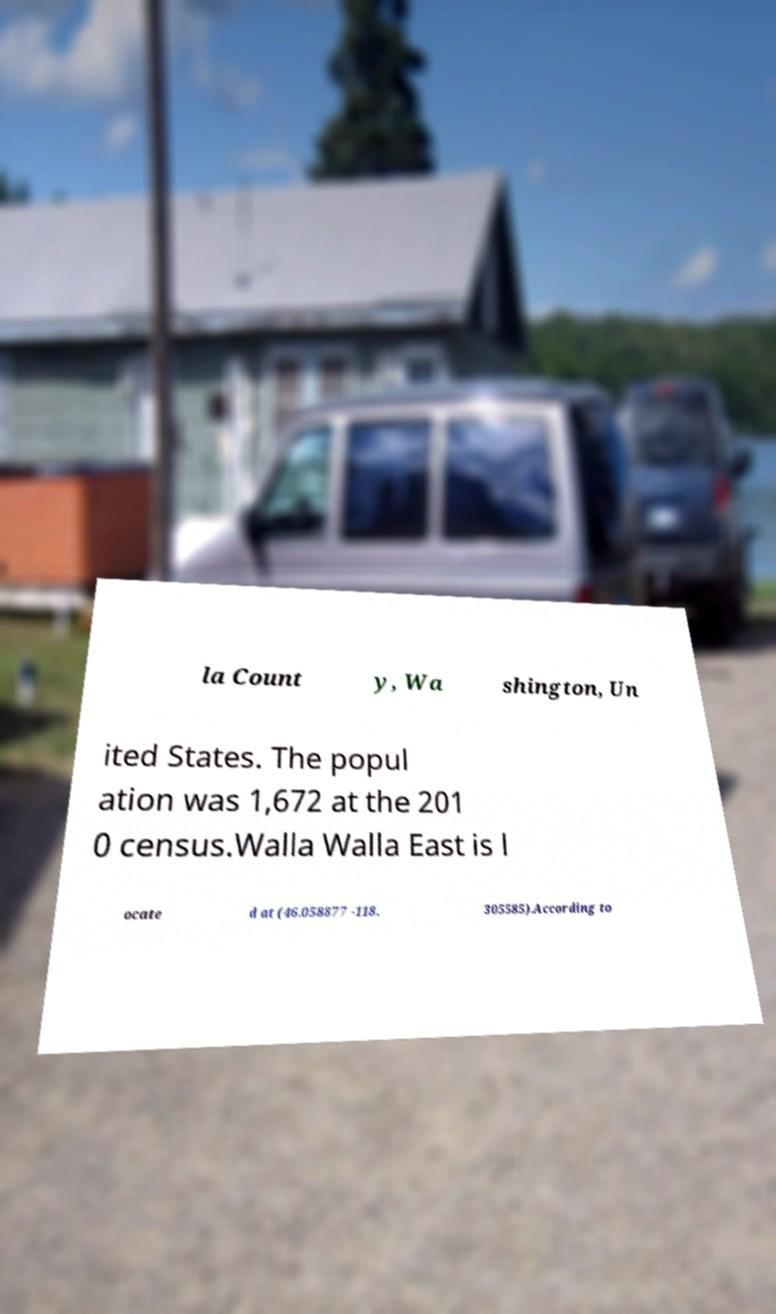Please read and relay the text visible in this image. What does it say? la Count y, Wa shington, Un ited States. The popul ation was 1,672 at the 201 0 census.Walla Walla East is l ocate d at (46.058877 -118. 305585).According to 